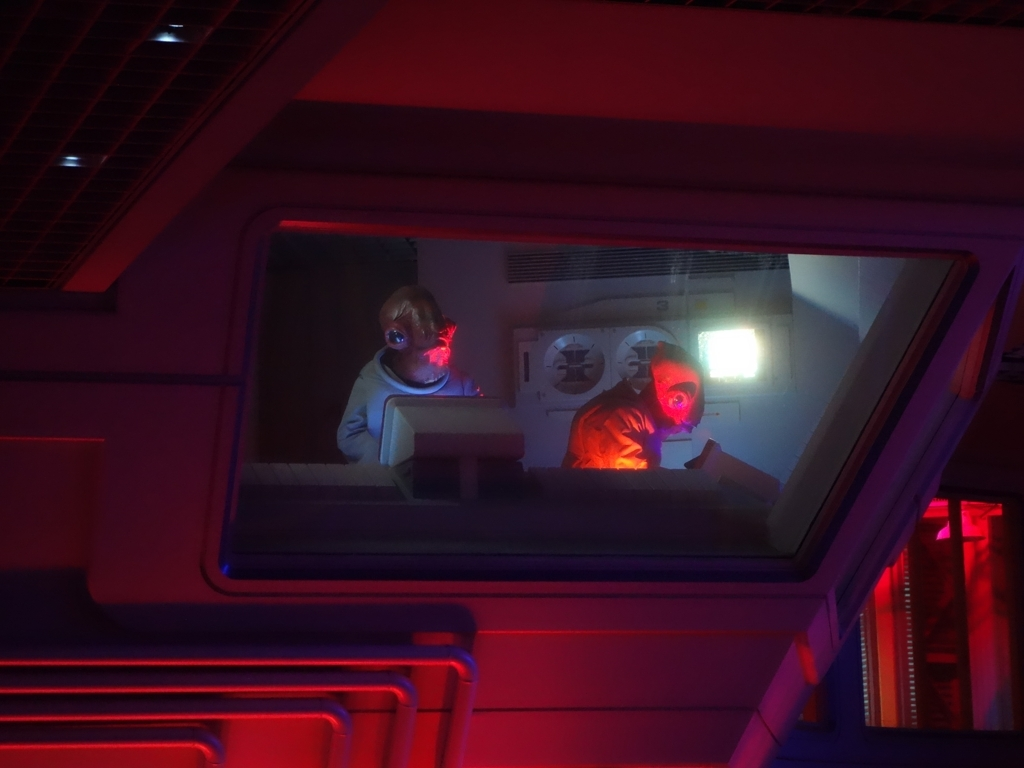Describe the mood of this image and what elements contribute to it. The mood of the image is mysterious and tense. Contributing elements include the shadowed environment pierced by pockets of vibrant color, which creates a visual contrast that adds to the intrigue. The characters' obscured faces and the focused light on their hands create a sense of urgency and concentration. The overall dark ambience, punctuated by the illuminated screens and colored lights, evokes a sense of isolation within a high-stakes setting. What sort of story elements or themes can you infer from this image? The image suggests themes of technological advancement, possibly with underlying ethical or moral questions common to science fiction narratives. One might infer a subplot of surveillance or monitoring, given the array of screens and the characters' rapt attention. Additionally, the stark lighting contrasts could imply dualities such as control versus freedom, safety versus danger, or visible versus hidden truths. The encapsulated scene beckons the viewer to consider broader story arcs involving space exploration, human-machine interaction, or the balance between knowledge and the responsibilities it carries. 